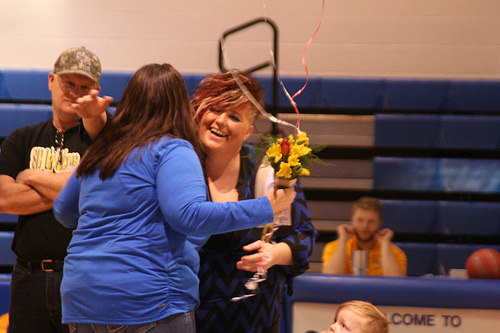<image>
Is there a man to the left of the girl? No. The man is not to the left of the girl. From this viewpoint, they have a different horizontal relationship. 